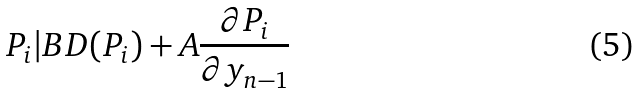Convert formula to latex. <formula><loc_0><loc_0><loc_500><loc_500>P _ { i } | B D ( P _ { i } ) + A \frac { \partial P _ { i } } { \partial y _ { n - 1 } }</formula> 